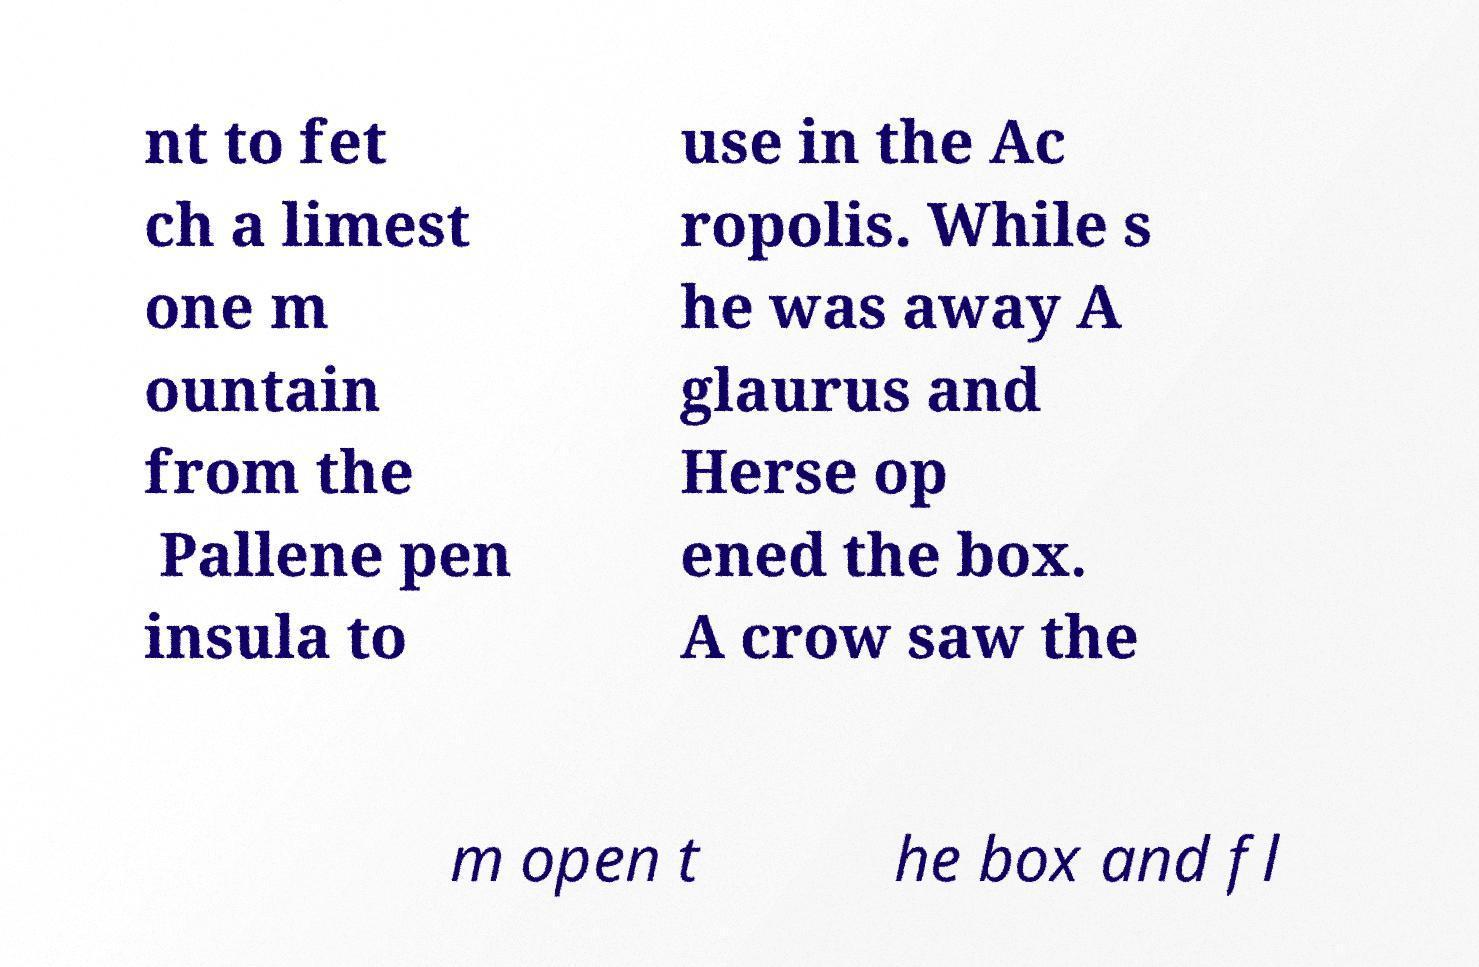Please read and relay the text visible in this image. What does it say? nt to fet ch a limest one m ountain from the Pallene pen insula to use in the Ac ropolis. While s he was away A glaurus and Herse op ened the box. A crow saw the m open t he box and fl 